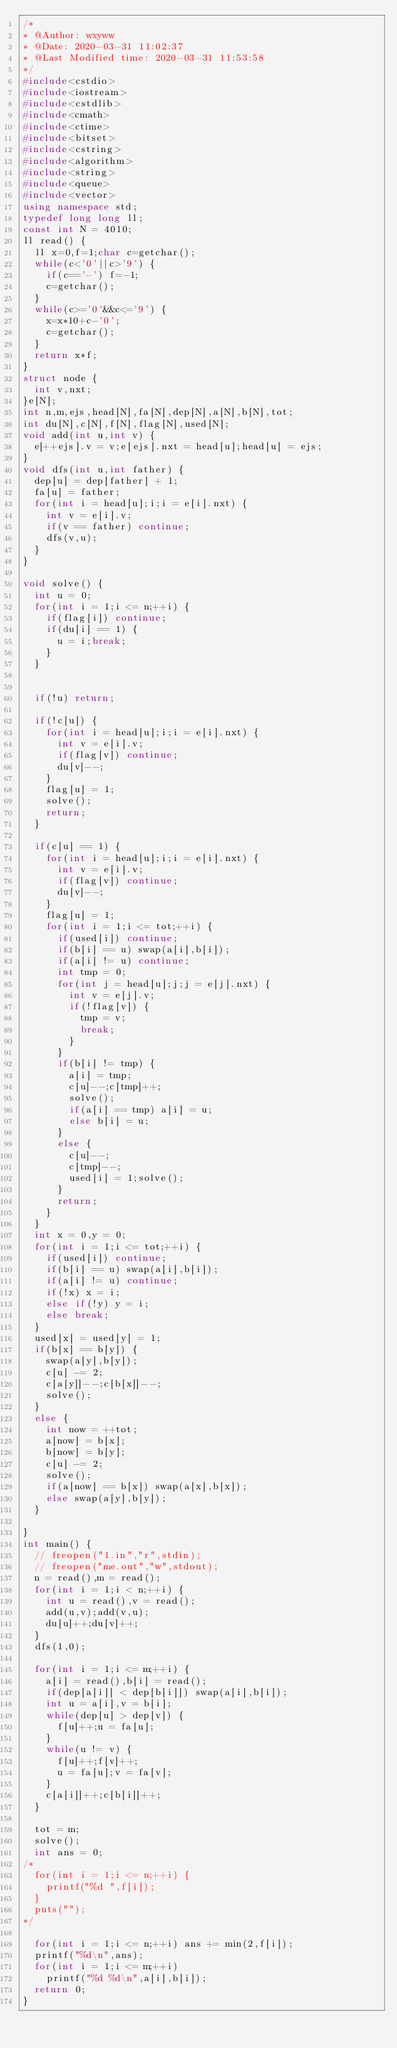<code> <loc_0><loc_0><loc_500><loc_500><_C++_>/*
* @Author: wxyww
* @Date: 2020-03-31 11:02:37
* @Last Modified time: 2020-03-31 11:53:58
*/
#include<cstdio>
#include<iostream>
#include<cstdlib>
#include<cmath>
#include<ctime>
#include<bitset>
#include<cstring>
#include<algorithm>
#include<string>
#include<queue>
#include<vector>
using namespace std;
typedef long long ll;
const int N = 4010;
ll read() {
	ll x=0,f=1;char c=getchar();
	while(c<'0'||c>'9') {
		if(c=='-') f=-1;
		c=getchar();
	}
	while(c>='0'&&c<='9') {
		x=x*10+c-'0';
		c=getchar();
	}
	return x*f;
}
struct node {
	int v,nxt;
}e[N];
int n,m,ejs,head[N],fa[N],dep[N],a[N],b[N],tot;
int du[N],c[N],f[N],flag[N],used[N];
void add(int u,int v) {
	e[++ejs].v = v;e[ejs].nxt = head[u];head[u] = ejs;
}
void dfs(int u,int father) {
	dep[u] = dep[father] + 1;
	fa[u] = father;
	for(int i = head[u];i;i = e[i].nxt) {
		int v = e[i].v;
		if(v == father) continue;
		dfs(v,u);
	}
}

void solve() {
	int u = 0;
	for(int i = 1;i <= n;++i) {
		if(flag[i]) continue;
		if(du[i] == 1) {
			u = i;break;
		}
	}


	if(!u) return;

	if(!c[u]) {
		for(int i = head[u];i;i = e[i].nxt) {
			int v = e[i].v;
			if(flag[v]) continue;
			du[v]--;
		}
		flag[u] = 1;
		solve();
		return;
	}

	if(c[u] == 1) {
		for(int i = head[u];i;i = e[i].nxt) {
			int v = e[i].v;
			if(flag[v]) continue;
			du[v]--;
		}
		flag[u] = 1;
		for(int i = 1;i <= tot;++i) {
			if(used[i]) continue;
			if(b[i] == u) swap(a[i],b[i]);
			if(a[i] != u) continue;
			int tmp = 0;
			for(int j = head[u];j;j = e[j].nxt) {
				int v = e[j].v;
				if(!flag[v]) {
					tmp = v; 
					break;
				}
			}
			if(b[i] != tmp) {
				a[i] = tmp;
				c[u]--;c[tmp]++;
				solve();
				if(a[i] == tmp) a[i] = u;
				else b[i] = u;
			}
			else {
				c[u]--;
				c[tmp]--;
				used[i] = 1;solve();
			}
			return;
		}
	}
	int x = 0,y = 0;
	for(int i = 1;i <= tot;++i) {
		if(used[i]) continue;
		if(b[i] == u) swap(a[i],b[i]);
		if(a[i] != u) continue;
		if(!x) x = i;
		else if(!y) y = i;
		else break;
	}
	used[x] = used[y] = 1;
	if(b[x] == b[y]) {
		swap(a[y],b[y]);
		c[u] -= 2;
		c[a[y]]--;c[b[x]]--;
		solve();
	}
	else {
		int now = ++tot;
		a[now] = b[x];
		b[now] = b[y];
		c[u] -= 2;
		solve();
		if(a[now] == b[x]) swap(a[x],b[x]);
		else swap(a[y],b[y]);
	}

}
int main() {
	// freopen("1.in","r",stdin);
	// freopen("me.out","w",stdout);
	n = read(),m = read();
	for(int i = 1;i < n;++i) {
		int u = read(),v = read();
		add(u,v);add(v,u);
		du[u]++;du[v]++;
	}
	dfs(1,0);

	for(int i = 1;i <= m;++i) {
		a[i] = read(),b[i] = read();
		if(dep[a[i]] < dep[b[i]]) swap(a[i],b[i]);
		int u = a[i],v = b[i];
		while(dep[u] > dep[v]) {
			f[u]++;u = fa[u];
		}
		while(u != v) {
			f[u]++;f[v]++;
			u = fa[u];v = fa[v];
		}
		c[a[i]]++;c[b[i]]++;
	}

	tot = m;
	solve();
	int ans = 0;
/*
	for(int i = 1;i <= n;++i) {
		printf("%d ",f[i]);
	}
	puts("");
*/

	for(int i = 1;i <= n;++i) ans += min(2,f[i]);
	printf("%d\n",ans);
	for(int i = 1;i <= m;++i)
		printf("%d %d\n",a[i],b[i]);
	return 0;
}</code> 